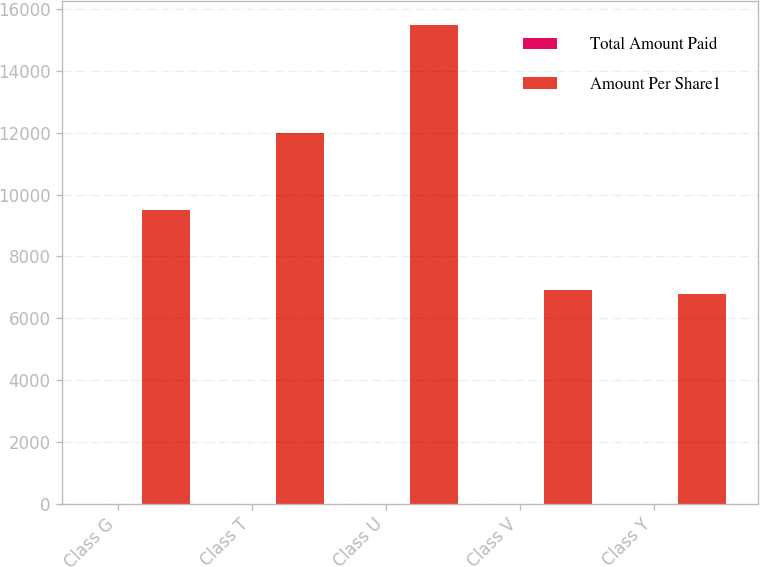Convert chart to OTSL. <chart><loc_0><loc_0><loc_500><loc_500><stacked_bar_chart><ecel><fcel>Class G<fcel>Class T<fcel>Class U<fcel>Class V<fcel>Class Y<nl><fcel>Total Amount Paid<fcel>2.34<fcel>2<fcel>1.94<fcel>2<fcel>1.97<nl><fcel>Amount Per Share1<fcel>9492<fcel>12000<fcel>15500<fcel>6900<fcel>6792<nl></chart> 